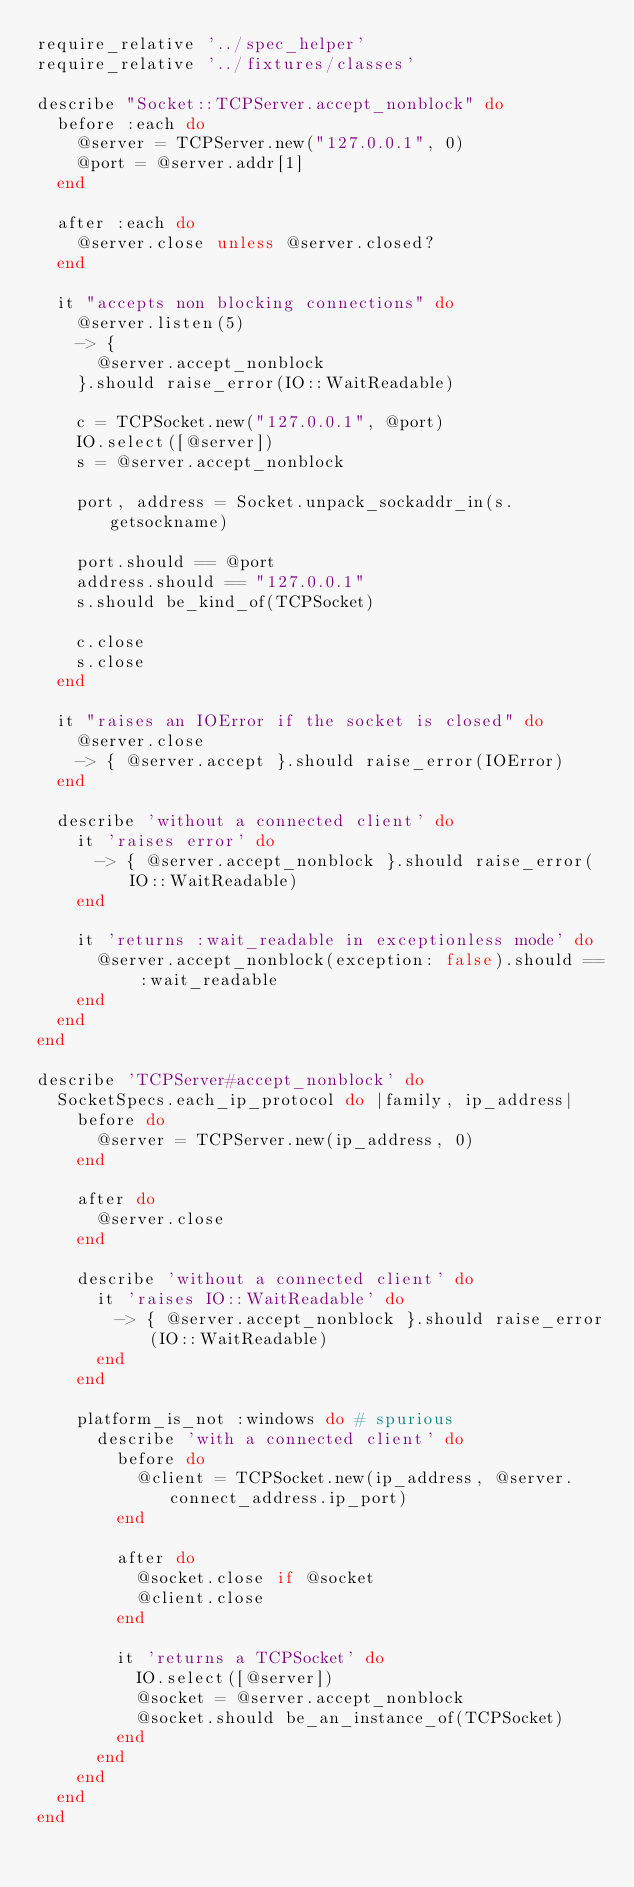Convert code to text. <code><loc_0><loc_0><loc_500><loc_500><_Ruby_>require_relative '../spec_helper'
require_relative '../fixtures/classes'

describe "Socket::TCPServer.accept_nonblock" do
  before :each do
    @server = TCPServer.new("127.0.0.1", 0)
    @port = @server.addr[1]
  end

  after :each do
    @server.close unless @server.closed?
  end

  it "accepts non blocking connections" do
    @server.listen(5)
    -> {
      @server.accept_nonblock
    }.should raise_error(IO::WaitReadable)

    c = TCPSocket.new("127.0.0.1", @port)
    IO.select([@server])
    s = @server.accept_nonblock

    port, address = Socket.unpack_sockaddr_in(s.getsockname)

    port.should == @port
    address.should == "127.0.0.1"
    s.should be_kind_of(TCPSocket)

    c.close
    s.close
  end

  it "raises an IOError if the socket is closed" do
    @server.close
    -> { @server.accept }.should raise_error(IOError)
  end

  describe 'without a connected client' do
    it 'raises error' do
      -> { @server.accept_nonblock }.should raise_error(IO::WaitReadable)
    end

    it 'returns :wait_readable in exceptionless mode' do
      @server.accept_nonblock(exception: false).should == :wait_readable
    end
  end
end

describe 'TCPServer#accept_nonblock' do
  SocketSpecs.each_ip_protocol do |family, ip_address|
    before do
      @server = TCPServer.new(ip_address, 0)
    end

    after do
      @server.close
    end

    describe 'without a connected client' do
      it 'raises IO::WaitReadable' do
        -> { @server.accept_nonblock }.should raise_error(IO::WaitReadable)
      end
    end

    platform_is_not :windows do # spurious
      describe 'with a connected client' do
        before do
          @client = TCPSocket.new(ip_address, @server.connect_address.ip_port)
        end

        after do
          @socket.close if @socket
          @client.close
        end

        it 'returns a TCPSocket' do
          IO.select([@server])
          @socket = @server.accept_nonblock
          @socket.should be_an_instance_of(TCPSocket)
        end
      end
    end
  end
end
</code> 